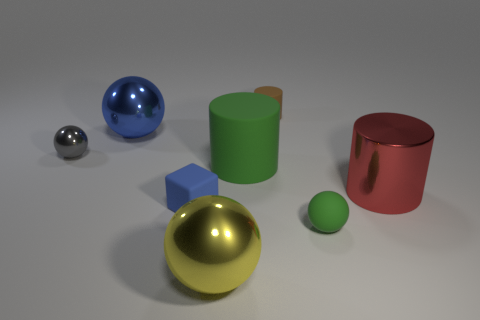Does the tiny blue object have the same material as the yellow ball?
Your answer should be very brief. No. What number of small things are the same material as the big green thing?
Keep it short and to the point. 3. There is a blue sphere; does it have the same size as the green thing that is behind the small matte block?
Provide a short and direct response. Yes. What is the color of the small thing that is left of the green cylinder and on the right side of the gray shiny object?
Give a very brief answer. Blue. There is a green matte object to the left of the small green thing; is there a large yellow object on the left side of it?
Provide a short and direct response. Yes. Are there an equal number of tiny gray shiny spheres left of the small metal thing and purple metal spheres?
Offer a terse response. Yes. What number of red metallic cylinders are in front of the ball that is to the right of the rubber object behind the blue shiny object?
Your answer should be compact. 0. Is there a cube of the same size as the blue sphere?
Offer a very short reply. No. Are there fewer small gray metal spheres on the left side of the small gray metal sphere than purple rubber cubes?
Give a very brief answer. No. What is the material of the large ball that is in front of the large shiny thing to the right of the green thing right of the tiny brown matte cylinder?
Provide a succinct answer. Metal. 